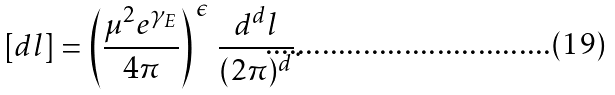<formula> <loc_0><loc_0><loc_500><loc_500>[ d l ] = \left ( \frac { \mu ^ { 2 } e ^ { \gamma _ { E } } } { 4 \pi } \right ) ^ { \, \epsilon } \, \frac { d ^ { d } l } { ( 2 \pi ) ^ { d } } .</formula> 